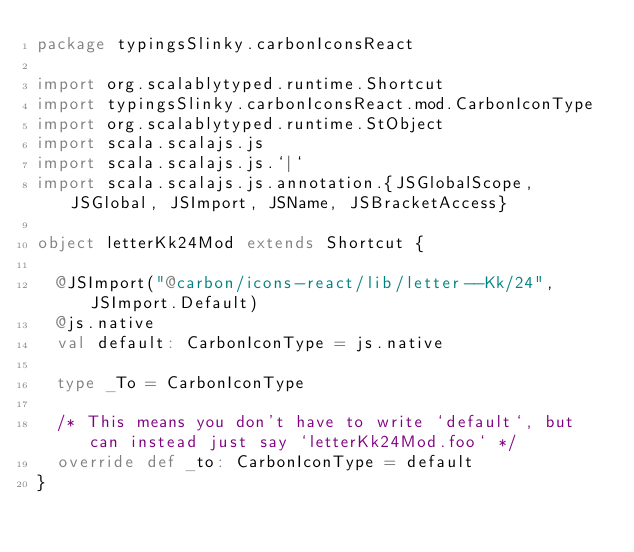Convert code to text. <code><loc_0><loc_0><loc_500><loc_500><_Scala_>package typingsSlinky.carbonIconsReact

import org.scalablytyped.runtime.Shortcut
import typingsSlinky.carbonIconsReact.mod.CarbonIconType
import org.scalablytyped.runtime.StObject
import scala.scalajs.js
import scala.scalajs.js.`|`
import scala.scalajs.js.annotation.{JSGlobalScope, JSGlobal, JSImport, JSName, JSBracketAccess}

object letterKk24Mod extends Shortcut {
  
  @JSImport("@carbon/icons-react/lib/letter--Kk/24", JSImport.Default)
  @js.native
  val default: CarbonIconType = js.native
  
  type _To = CarbonIconType
  
  /* This means you don't have to write `default`, but can instead just say `letterKk24Mod.foo` */
  override def _to: CarbonIconType = default
}
</code> 